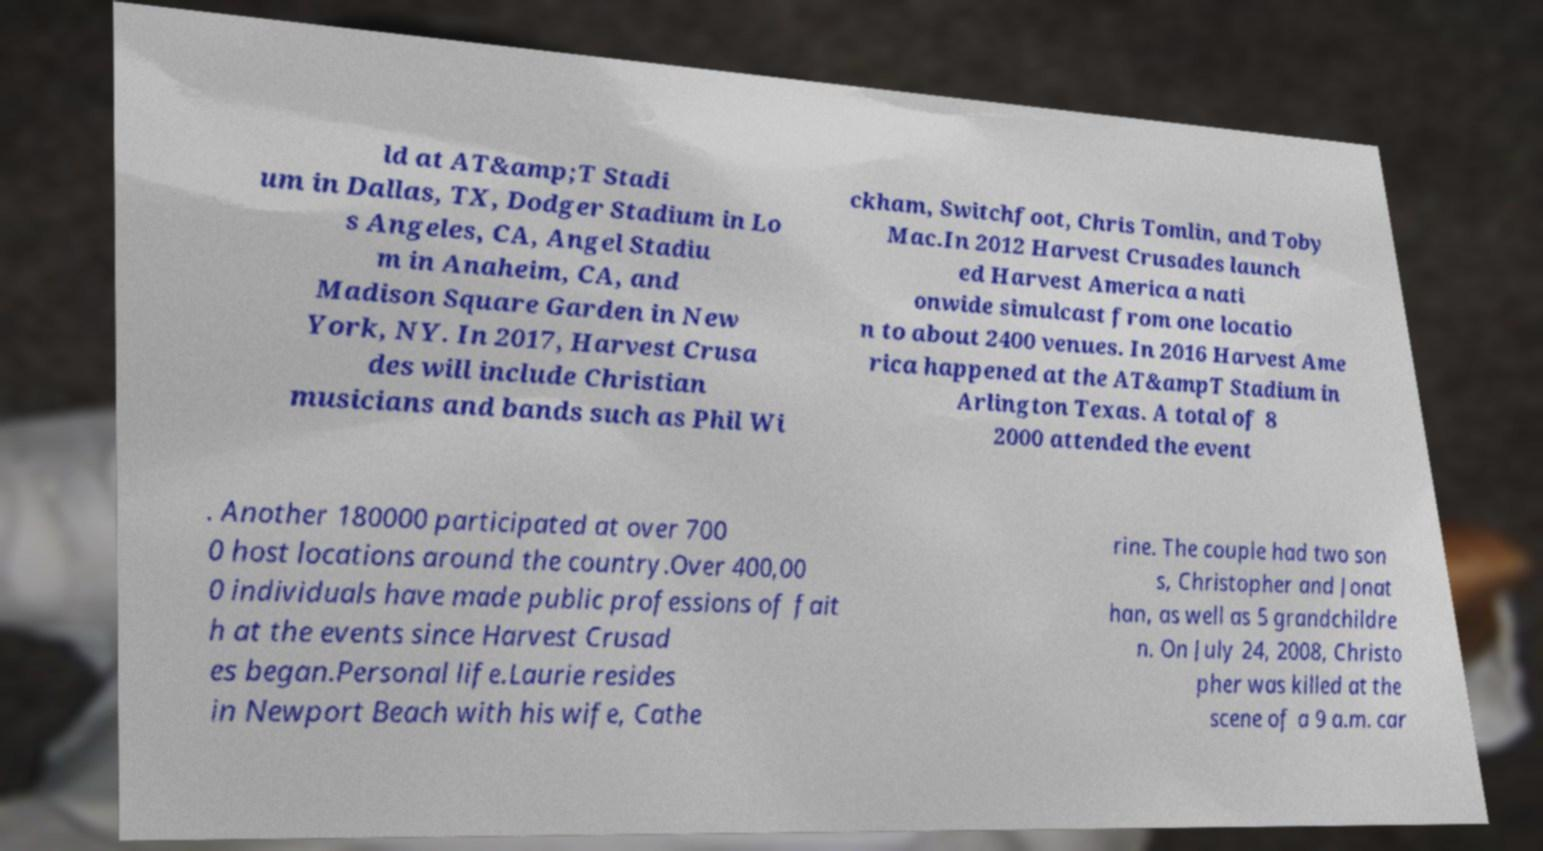I need the written content from this picture converted into text. Can you do that? ld at AT&amp;T Stadi um in Dallas, TX, Dodger Stadium in Lo s Angeles, CA, Angel Stadiu m in Anaheim, CA, and Madison Square Garden in New York, NY. In 2017, Harvest Crusa des will include Christian musicians and bands such as Phil Wi ckham, Switchfoot, Chris Tomlin, and Toby Mac.In 2012 Harvest Crusades launch ed Harvest America a nati onwide simulcast from one locatio n to about 2400 venues. In 2016 Harvest Ame rica happened at the AT&ampT Stadium in Arlington Texas. A total of 8 2000 attended the event . Another 180000 participated at over 700 0 host locations around the country.Over 400,00 0 individuals have made public professions of fait h at the events since Harvest Crusad es began.Personal life.Laurie resides in Newport Beach with his wife, Cathe rine. The couple had two son s, Christopher and Jonat han, as well as 5 grandchildre n. On July 24, 2008, Christo pher was killed at the scene of a 9 a.m. car 